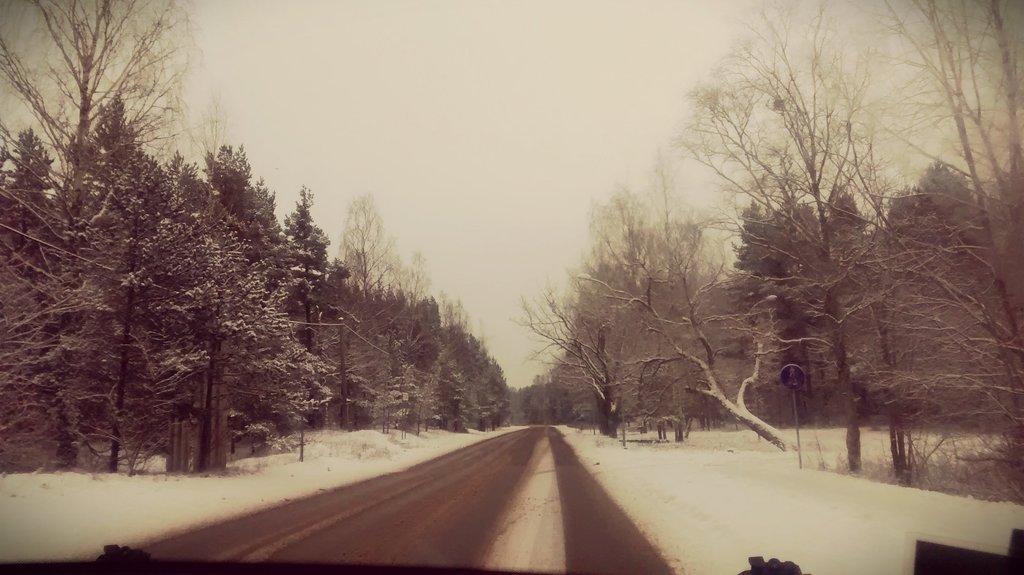Can you describe this image briefly? In this picture I can see the road in the middle, there are trees on either side of this image. There is the snow in the middle, at the top there is the sky. 